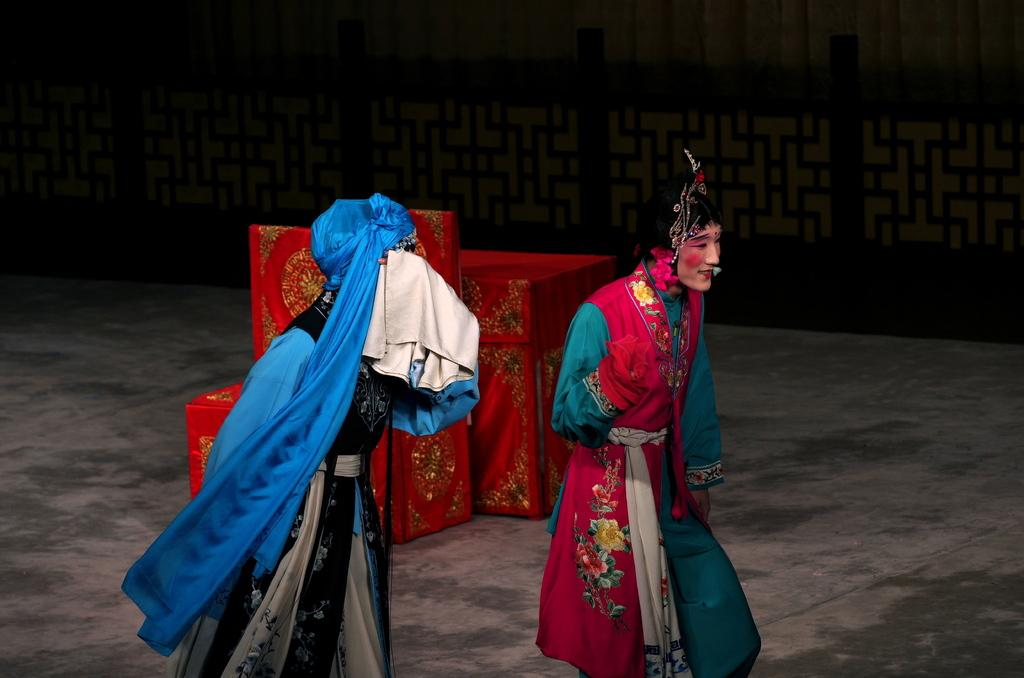Who or what can be seen in the front of the image? There are persons in the front of the image. What can be observed in the background of the image? There are objects in the background of the image. Can you describe the color of some of the objects in the background? Some of the objects in the background are red in color. Is there an object in the background that has a different color? Yes, there is an object in the background that is black in color. What type of glue is being used by the expert in the image? There is no expert or glue present in the image. 